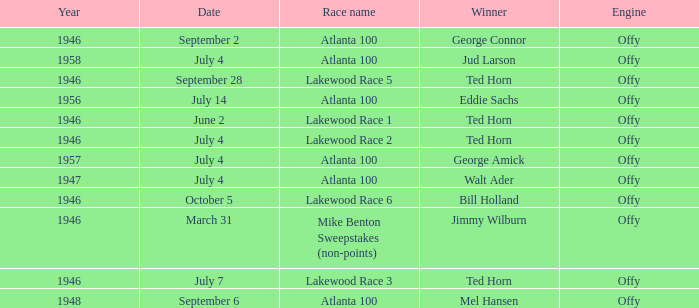Which race did Bill Holland win in 1946? Lakewood Race 6. 